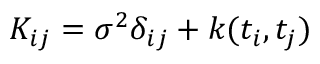Convert formula to latex. <formula><loc_0><loc_0><loc_500><loc_500>K _ { i j } = \sigma ^ { 2 } \delta _ { i j } + k ( t _ { i } , t _ { j } )</formula> 